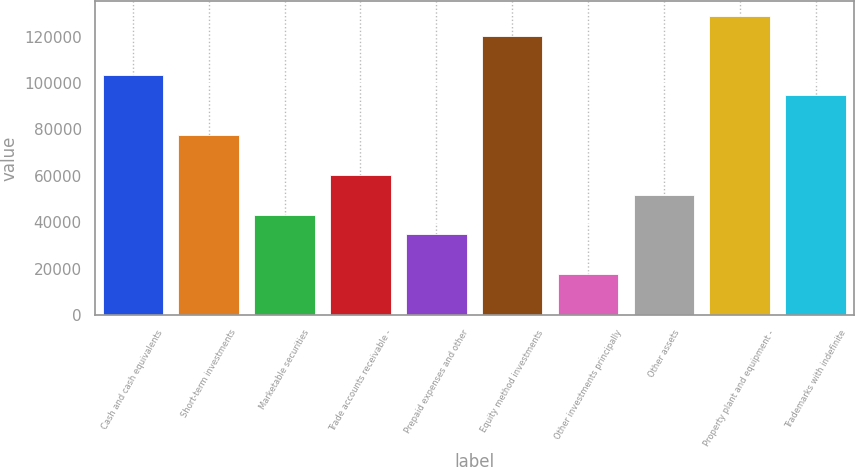Convert chart to OTSL. <chart><loc_0><loc_0><loc_500><loc_500><bar_chart><fcel>Cash and cash equivalents<fcel>Short-term investments<fcel>Marketable securities<fcel>Trade accounts receivable -<fcel>Prepaid expenses and other<fcel>Equity method investments<fcel>Other investments principally<fcel>Other assets<fcel>Property plant and equipment -<fcel>Trademarks with indefinite<nl><fcel>103315<fcel>77603.7<fcel>43322.5<fcel>60463.1<fcel>34752.2<fcel>120455<fcel>17611.6<fcel>51892.8<fcel>129026<fcel>94744.3<nl></chart> 